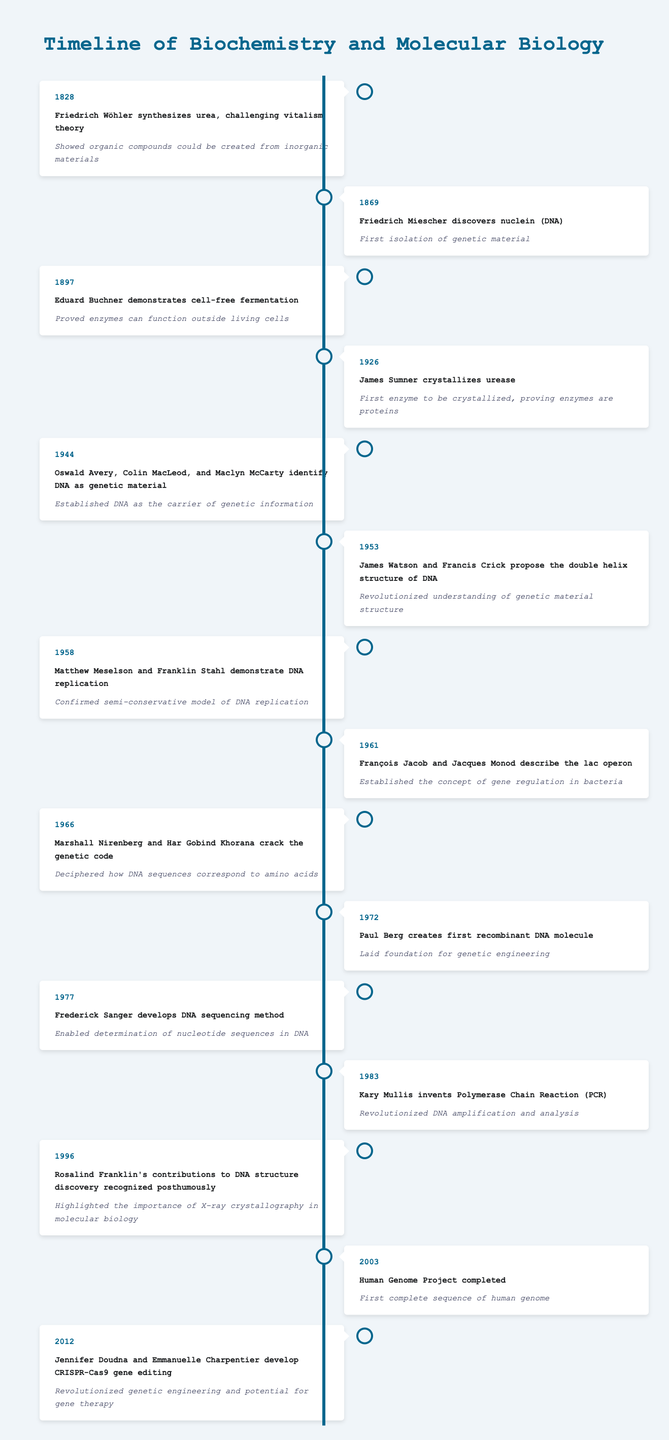What significant event occurred in 1828 related to biochemistry? In 1828, Friedrich Wöhler synthesized urea, which challenged the prevailing vitalism theory by demonstrating that organic compounds could be synthesized from inorganic materials.
Answer: Friedrich Wöhler synthesizes urea Which event confirmed that DNA is the carrier of genetic information? The event in 1944 where Oswald Avery, Colin MacLeod, and Maclyn McCarty identified DNA as the genetic material established it as the carrier of genetic information.
Answer: Oswald Avery, Colin MacLeod, and Maclyn McCarty identify DNA as genetic material How many years passed between the synthesis of urea by Wöhler and the completion of the Human Genome Project? The Human Genome Project was completed in 2003 and Wöhler synthesized urea in 1828. The difference in years is 2003 - 1828 = 175 years.
Answer: 175 years Did James Watson and Francis Crick propose the structure of DNA before the identification of DNA as genetic material? No, the identification of DNA as genetic material by Avery and colleagues occurred in 1944, while Watson and Crick proposed the double helix structure in 1953, which was after the identification.
Answer: No What was the significance of the event in 1983 in biochemistry? The invention of the Polymerase Chain Reaction (PCR) by Kary Mullis in 1983 revolutionized DNA amplification and analysis, significantly impacting molecular biology and genetics.
Answer: Revolutionized DNA amplification and analysis Combine the years of the events where the genetic code was cracked and when the first recombinant DNA molecule was created, then state the total. The genetic code was cracked in 1966 and the first recombinant DNA molecule was created in 1972. Therefore, the total is 1966 + 1972 = 3938.
Answer: 3938 What major discovery about enzymes was made in 1897? The major discovery made in 1897 by Eduard Buchner was that enzymes could function outside living cells, demonstrating that cell-free fermentation is possible.
Answer: Proved enzymes can function outside living cells Identify the first crystallized enzyme and its year of crystallization. The first enzyme to be crystallized was urease, which was crystallized by James Sumner in 1926.
Answer: Urease, 1926 In what year was the CRISPR-Cas9 gene editing developed and what was its impact on genetics? Jennifer Doudna and Emmanuelle Charpentier developed CRISPR-Cas9 gene editing in 2012. This technology revolutionized genetic engineering and has potential applications in gene therapy, allowing for precise edits to DNA.
Answer: 2012; revolutionized genetic engineering 